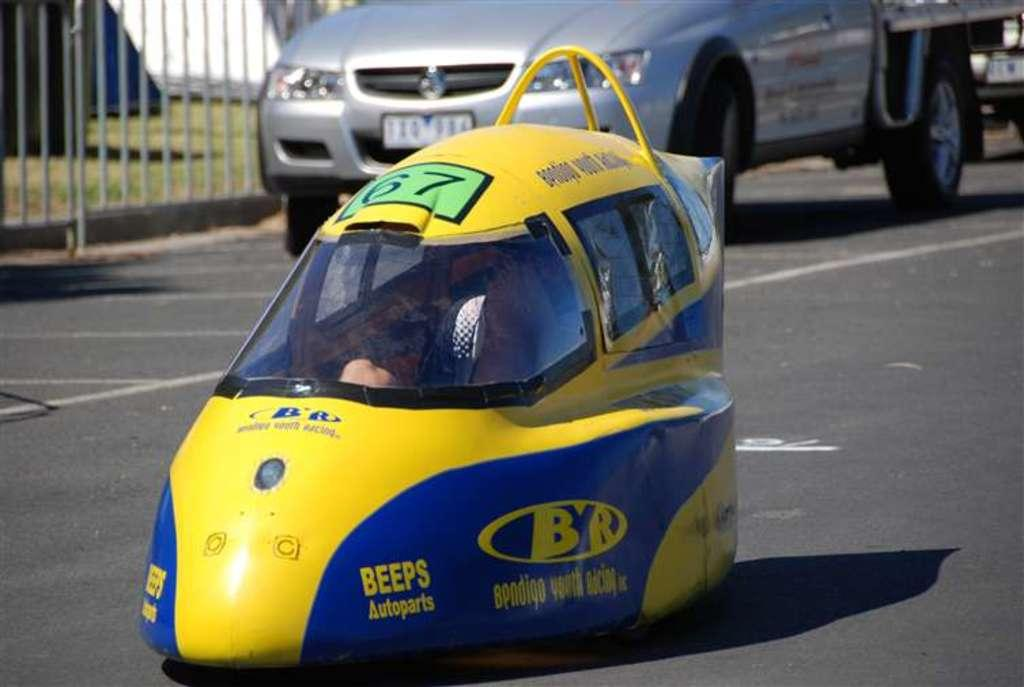<image>
Render a clear and concise summary of the photo. A very strange car thing with the word BEEPS Autoparts on the front. 